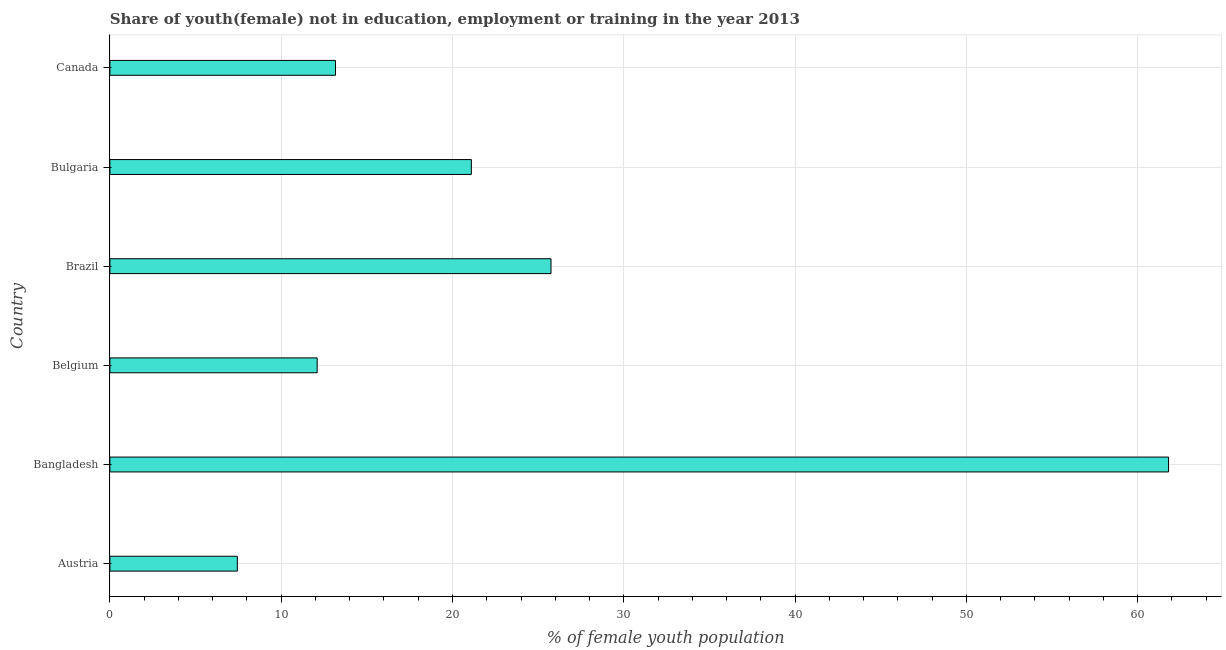Does the graph contain any zero values?
Keep it short and to the point. No. Does the graph contain grids?
Your response must be concise. Yes. What is the title of the graph?
Give a very brief answer. Share of youth(female) not in education, employment or training in the year 2013. What is the label or title of the X-axis?
Ensure brevity in your answer.  % of female youth population. What is the unemployed female youth population in Bangladesh?
Your response must be concise. 61.8. Across all countries, what is the maximum unemployed female youth population?
Ensure brevity in your answer.  61.8. Across all countries, what is the minimum unemployed female youth population?
Offer a very short reply. 7.44. In which country was the unemployed female youth population maximum?
Your answer should be compact. Bangladesh. In which country was the unemployed female youth population minimum?
Give a very brief answer. Austria. What is the sum of the unemployed female youth population?
Make the answer very short. 141.36. What is the difference between the unemployed female youth population in Austria and Bangladesh?
Ensure brevity in your answer.  -54.36. What is the average unemployed female youth population per country?
Make the answer very short. 23.56. What is the median unemployed female youth population?
Keep it short and to the point. 17.14. In how many countries, is the unemployed female youth population greater than 56 %?
Your response must be concise. 1. What is the ratio of the unemployed female youth population in Bangladesh to that in Brazil?
Your answer should be compact. 2.4. Is the unemployed female youth population in Austria less than that in Canada?
Your answer should be compact. Yes. Is the difference between the unemployed female youth population in Austria and Bulgaria greater than the difference between any two countries?
Provide a short and direct response. No. What is the difference between the highest and the second highest unemployed female youth population?
Provide a succinct answer. 36.05. Is the sum of the unemployed female youth population in Brazil and Bulgaria greater than the maximum unemployed female youth population across all countries?
Your answer should be compact. No. What is the difference between the highest and the lowest unemployed female youth population?
Keep it short and to the point. 54.36. What is the difference between two consecutive major ticks on the X-axis?
Offer a very short reply. 10. What is the % of female youth population in Austria?
Provide a short and direct response. 7.44. What is the % of female youth population in Bangladesh?
Your response must be concise. 61.8. What is the % of female youth population in Belgium?
Provide a short and direct response. 12.1. What is the % of female youth population in Brazil?
Keep it short and to the point. 25.75. What is the % of female youth population of Bulgaria?
Provide a short and direct response. 21.1. What is the % of female youth population in Canada?
Keep it short and to the point. 13.17. What is the difference between the % of female youth population in Austria and Bangladesh?
Your answer should be compact. -54.36. What is the difference between the % of female youth population in Austria and Belgium?
Ensure brevity in your answer.  -4.66. What is the difference between the % of female youth population in Austria and Brazil?
Ensure brevity in your answer.  -18.31. What is the difference between the % of female youth population in Austria and Bulgaria?
Your response must be concise. -13.66. What is the difference between the % of female youth population in Austria and Canada?
Keep it short and to the point. -5.73. What is the difference between the % of female youth population in Bangladesh and Belgium?
Make the answer very short. 49.7. What is the difference between the % of female youth population in Bangladesh and Brazil?
Your answer should be compact. 36.05. What is the difference between the % of female youth population in Bangladesh and Bulgaria?
Offer a very short reply. 40.7. What is the difference between the % of female youth population in Bangladesh and Canada?
Offer a terse response. 48.63. What is the difference between the % of female youth population in Belgium and Brazil?
Ensure brevity in your answer.  -13.65. What is the difference between the % of female youth population in Belgium and Canada?
Keep it short and to the point. -1.07. What is the difference between the % of female youth population in Brazil and Bulgaria?
Keep it short and to the point. 4.65. What is the difference between the % of female youth population in Brazil and Canada?
Offer a very short reply. 12.58. What is the difference between the % of female youth population in Bulgaria and Canada?
Your answer should be very brief. 7.93. What is the ratio of the % of female youth population in Austria to that in Bangladesh?
Your answer should be very brief. 0.12. What is the ratio of the % of female youth population in Austria to that in Belgium?
Provide a succinct answer. 0.61. What is the ratio of the % of female youth population in Austria to that in Brazil?
Keep it short and to the point. 0.29. What is the ratio of the % of female youth population in Austria to that in Bulgaria?
Your response must be concise. 0.35. What is the ratio of the % of female youth population in Austria to that in Canada?
Provide a short and direct response. 0.56. What is the ratio of the % of female youth population in Bangladesh to that in Belgium?
Give a very brief answer. 5.11. What is the ratio of the % of female youth population in Bangladesh to that in Bulgaria?
Ensure brevity in your answer.  2.93. What is the ratio of the % of female youth population in Bangladesh to that in Canada?
Your answer should be compact. 4.69. What is the ratio of the % of female youth population in Belgium to that in Brazil?
Provide a succinct answer. 0.47. What is the ratio of the % of female youth population in Belgium to that in Bulgaria?
Your answer should be compact. 0.57. What is the ratio of the % of female youth population in Belgium to that in Canada?
Ensure brevity in your answer.  0.92. What is the ratio of the % of female youth population in Brazil to that in Bulgaria?
Offer a terse response. 1.22. What is the ratio of the % of female youth population in Brazil to that in Canada?
Make the answer very short. 1.96. What is the ratio of the % of female youth population in Bulgaria to that in Canada?
Make the answer very short. 1.6. 